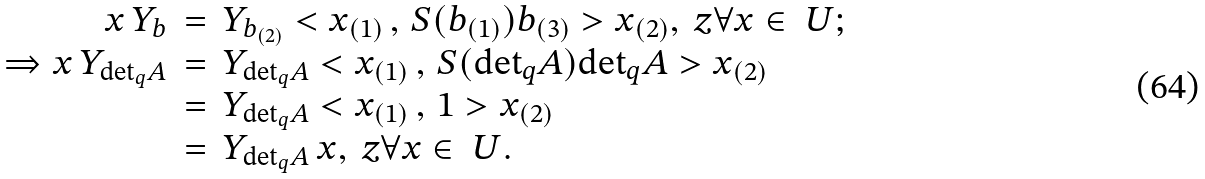<formula> <loc_0><loc_0><loc_500><loc_500>\begin{array} { r c l } x \, Y _ { b } & = & Y _ { b _ { ( 2 ) } } < x _ { ( 1 ) } \, , \, S ( b _ { ( 1 ) } ) b _ { ( 3 ) } > x _ { ( 2 ) } , \ z \forall x \in \ U ; \\ \Rightarrow x \, Y _ { { \det } _ { q } A } & = & Y _ { { \det } _ { q } A } < x _ { ( 1 ) } \, , \, S ( { \det } _ { q } A ) { \det } _ { q } A > x _ { ( 2 ) } \\ & = & Y _ { { \det } _ { q } A } < x _ { ( 1 ) } \, , \, 1 > x _ { ( 2 ) } \\ & = & Y _ { { \det } _ { q } A } \, x , \ z \forall x \in \ U . \end{array}</formula> 